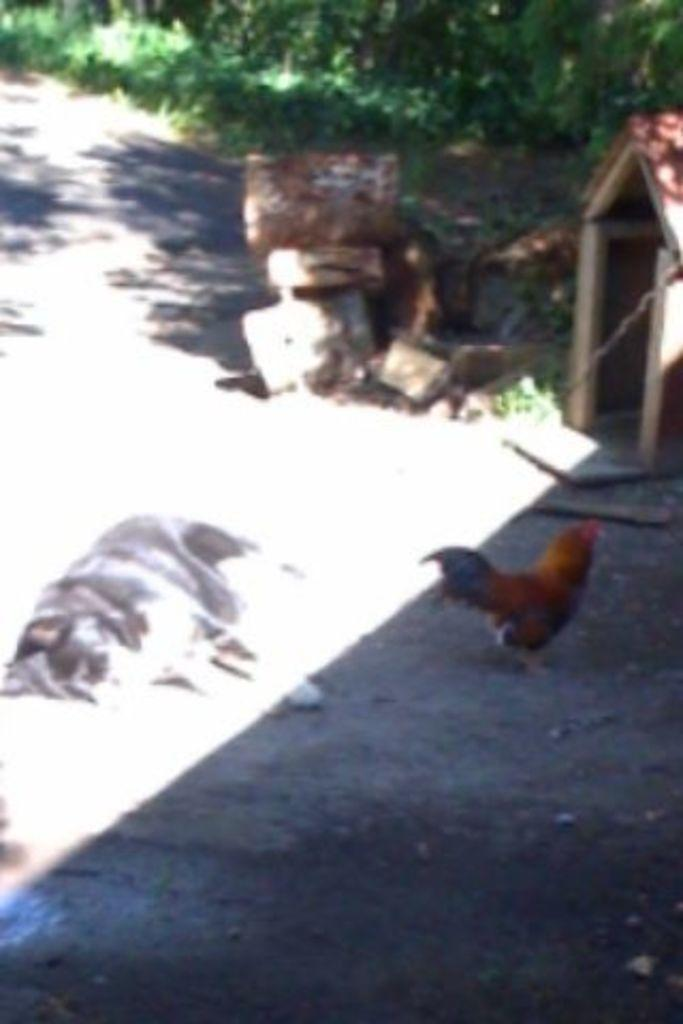What animal can be seen in the image? There is a dog in the image. What other creature is present in the image? There is a cock on the ground in the image. What can be seen in the distance in the image? There is a shed and plants in the background of the image. Are there any other objects visible in the background? Yes, there are some objects visible in the background of the image. What type of slip can be seen on the dog's paw in the image? There is no slip visible on the dog's paw in the image. Can you tell me how many beetles are crawling on the ground near the cock? There are no beetles present in the image; only the dog, cock, and objects in the background can be seen. 